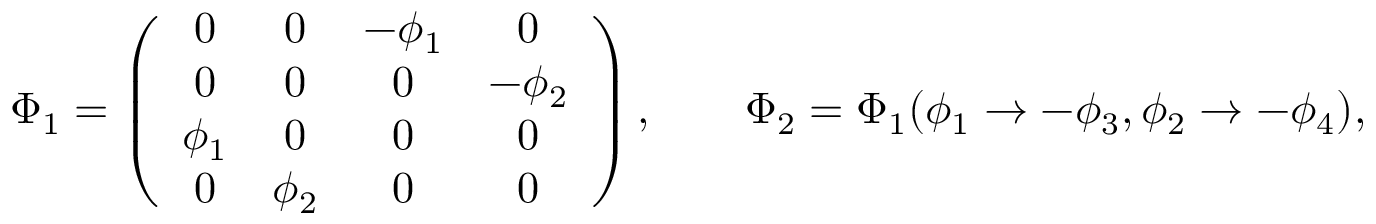Convert formula to latex. <formula><loc_0><loc_0><loc_500><loc_500>\Phi _ { 1 } = \left ( \begin{array} { c c c c } { 0 } & { 0 } & { { - \phi _ { 1 } } } & { 0 } \\ { 0 } & { 0 } & { 0 } & { { - \phi _ { 2 } } } \\ { { \phi _ { 1 } } } & { 0 } & { 0 } & { 0 } \\ { 0 } & { { \phi _ { 2 } } } & { 0 } & { 0 } \end{array} \right ) , \quad \Phi _ { 2 } = \Phi _ { 1 } ( \phi _ { 1 } \to - \phi _ { 3 } , \phi _ { 2 } \to - \phi _ { 4 } ) ,</formula> 